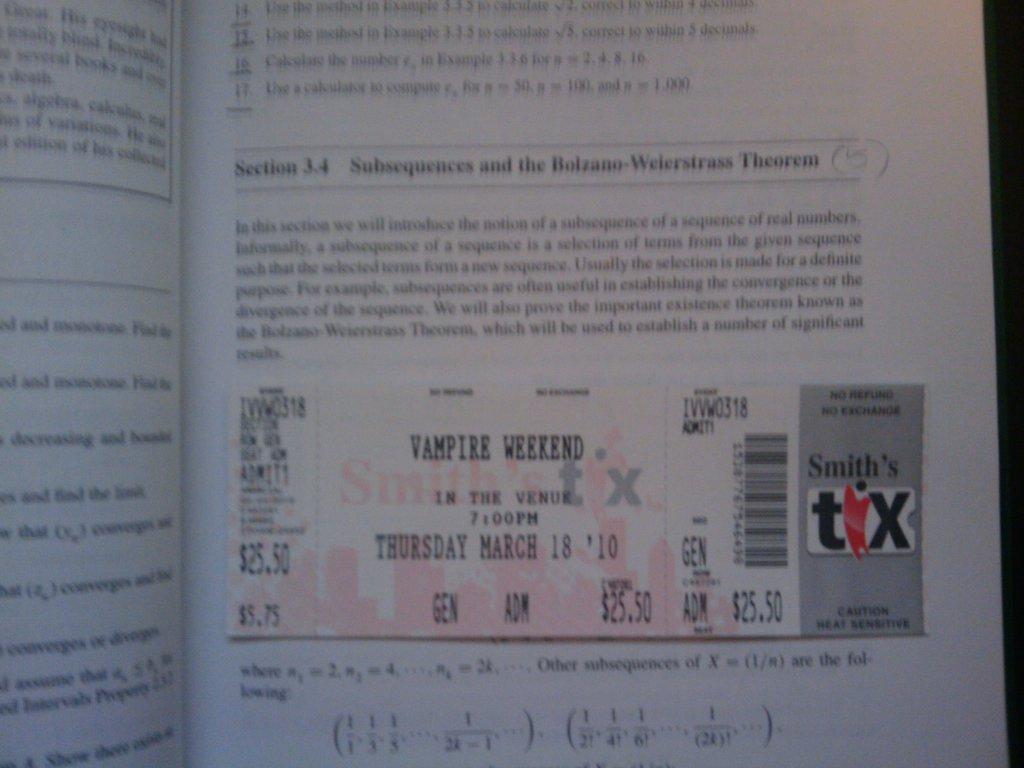What's the date on the ticket say?
Provide a short and direct response. March 18 2010. How much did this ticket cost?
Your answer should be compact. $25.50. 